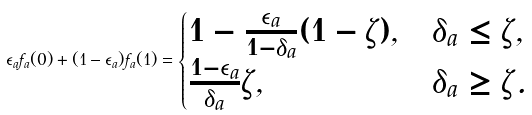<formula> <loc_0><loc_0><loc_500><loc_500>\epsilon _ { a } f _ { a } ( 0 ) + ( 1 - \epsilon _ { a } ) f _ { a } ( 1 ) = \begin{cases} 1 - \frac { \epsilon _ { a } } { 1 - \delta _ { a } } ( 1 - \zeta ) , & \delta _ { a } \leq \zeta , \\ \frac { 1 - \epsilon _ { a } } { \delta _ { a } } \zeta , & \delta _ { a } \geq \zeta . \\ \end{cases}</formula> 